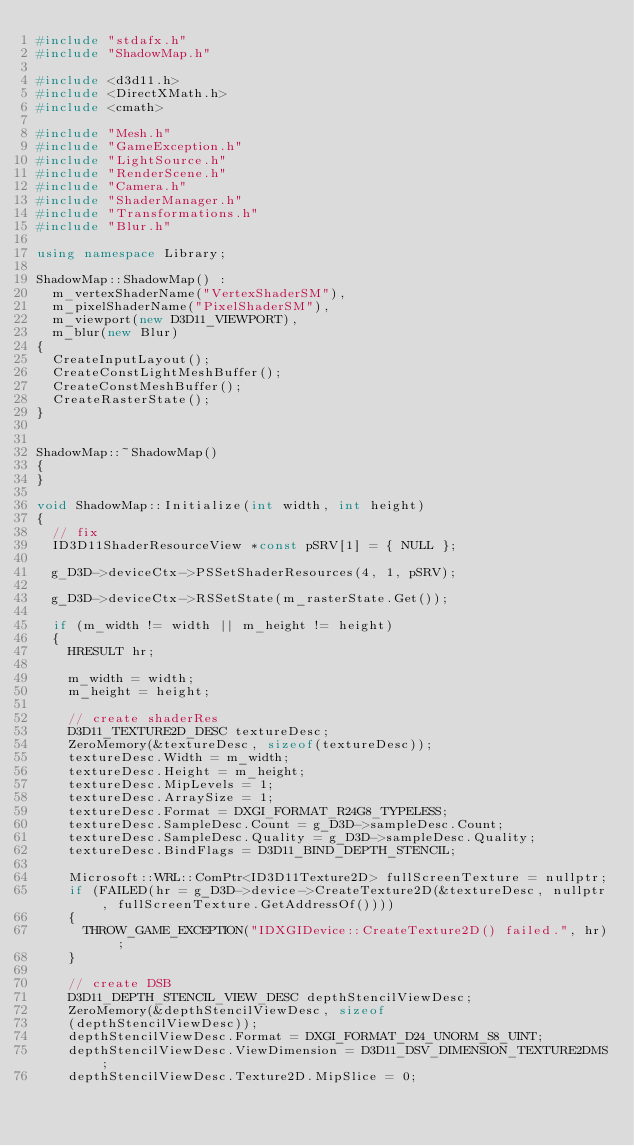Convert code to text. <code><loc_0><loc_0><loc_500><loc_500><_C++_>#include "stdafx.h"
#include "ShadowMap.h"

#include <d3d11.h>
#include <DirectXMath.h>
#include <cmath>

#include "Mesh.h"
#include "GameException.h"
#include "LightSource.h"
#include "RenderScene.h"
#include "Camera.h"
#include "ShaderManager.h"
#include "Transformations.h"
#include "Blur.h"

using namespace Library;

ShadowMap::ShadowMap() :
	m_vertexShaderName("VertexShaderSM"),
	m_pixelShaderName("PixelShaderSM"),
	m_viewport(new D3D11_VIEWPORT),
	m_blur(new Blur)
{
	CreateInputLayout();
	CreateConstLightMeshBuffer();
	CreateConstMeshBuffer();
	CreateRasterState();
}


ShadowMap::~ShadowMap()
{
}

void ShadowMap::Initialize(int width, int height)
{
	// fix
	ID3D11ShaderResourceView *const pSRV[1] = { NULL };
	
	g_D3D->deviceCtx->PSSetShaderResources(4, 1, pSRV);

	g_D3D->deviceCtx->RSSetState(m_rasterState.Get());

	if (m_width != width || m_height != height)
	{	
		HRESULT hr;

		m_width = width;
		m_height = height;

		// create shaderRes
		D3D11_TEXTURE2D_DESC textureDesc;
		ZeroMemory(&textureDesc, sizeof(textureDesc));
		textureDesc.Width = m_width;
		textureDesc.Height = m_height;
		textureDesc.MipLevels = 1;
		textureDesc.ArraySize = 1;
		textureDesc.Format = DXGI_FORMAT_R24G8_TYPELESS;
		textureDesc.SampleDesc.Count = g_D3D->sampleDesc.Count;
		textureDesc.SampleDesc.Quality = g_D3D->sampleDesc.Quality;
		textureDesc.BindFlags = D3D11_BIND_DEPTH_STENCIL;

		Microsoft::WRL::ComPtr<ID3D11Texture2D> fullScreenTexture = nullptr;
		if (FAILED(hr = g_D3D->device->CreateTexture2D(&textureDesc, nullptr, fullScreenTexture.GetAddressOf())))
		{
			THROW_GAME_EXCEPTION("IDXGIDevice::CreateTexture2D() failed.", hr);
		}

		// create DSB
		D3D11_DEPTH_STENCIL_VIEW_DESC depthStencilViewDesc;
		ZeroMemory(&depthStencilViewDesc, sizeof
		(depthStencilViewDesc));
		depthStencilViewDesc.Format = DXGI_FORMAT_D24_UNORM_S8_UINT;
		depthStencilViewDesc.ViewDimension = D3D11_DSV_DIMENSION_TEXTURE2DMS;
		depthStencilViewDesc.Texture2D.MipSlice = 0;
</code> 